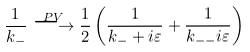Convert formula to latex. <formula><loc_0><loc_0><loc_500><loc_500>\frac { 1 } { k _ { - } } \stackrel { P V } { \longrightarrow } \frac { 1 } { 2 } \left ( \frac { 1 } { k _ { - } + i \varepsilon } + \frac { 1 } { k _ { - - } i \varepsilon } \right )</formula> 